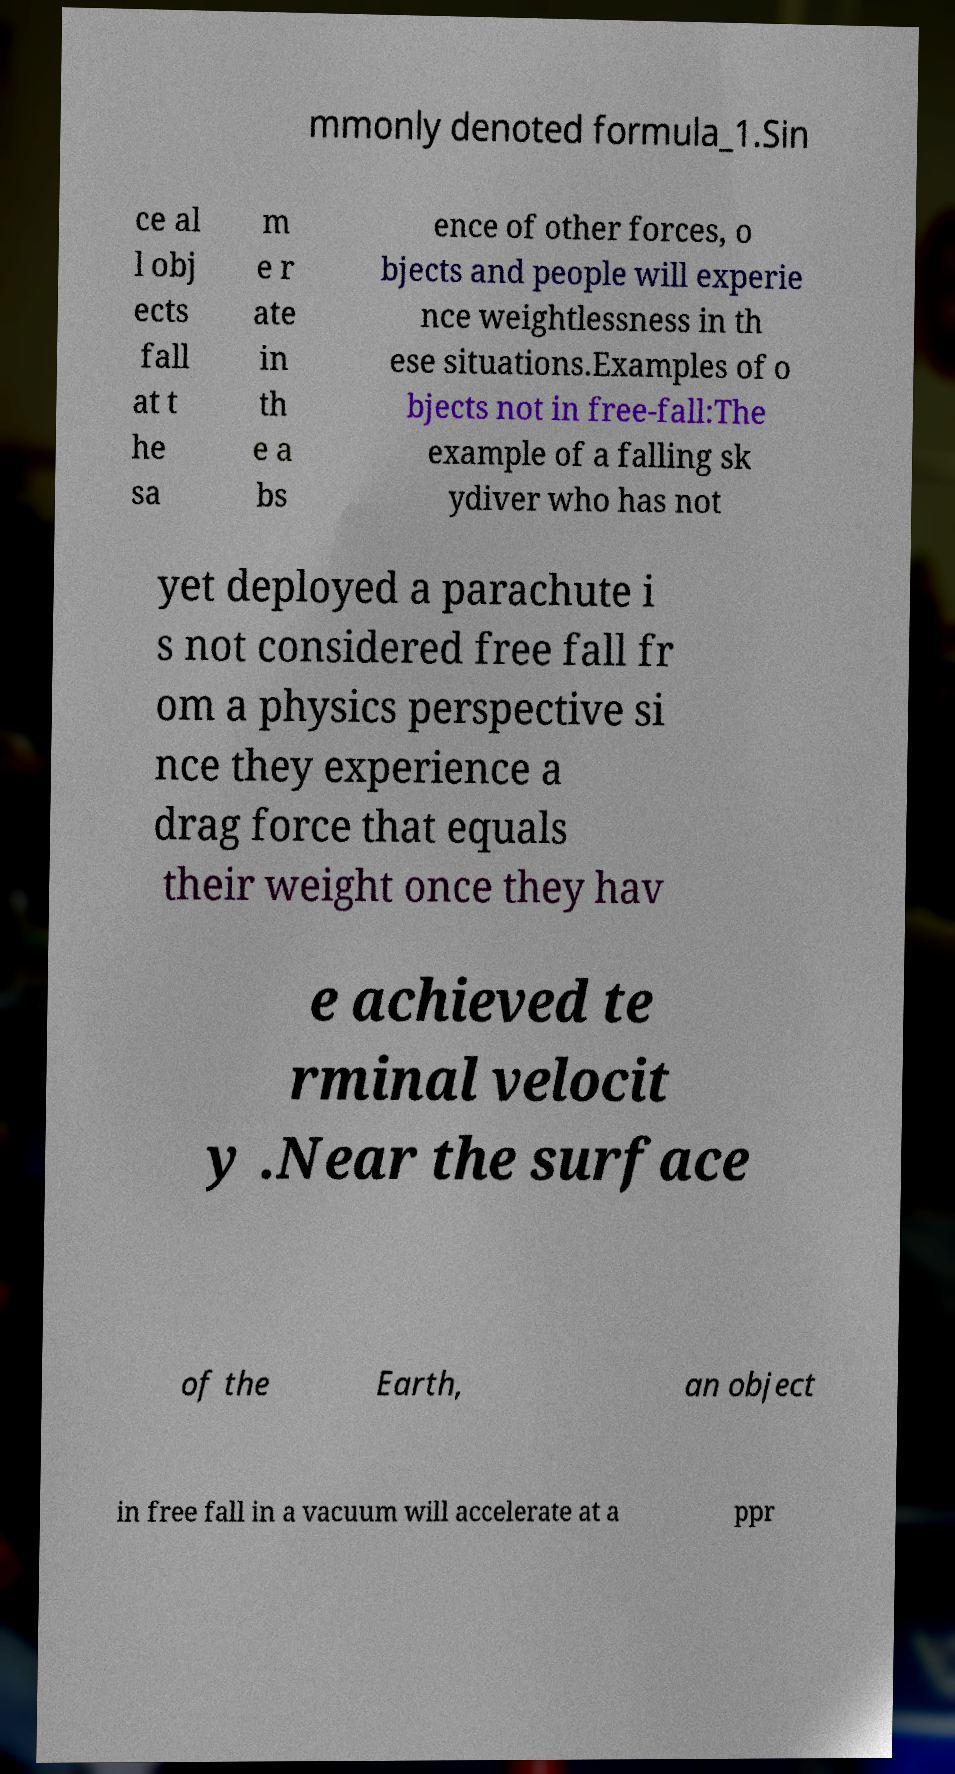There's text embedded in this image that I need extracted. Can you transcribe it verbatim? mmonly denoted formula_1.Sin ce al l obj ects fall at t he sa m e r ate in th e a bs ence of other forces, o bjects and people will experie nce weightlessness in th ese situations.Examples of o bjects not in free-fall:The example of a falling sk ydiver who has not yet deployed a parachute i s not considered free fall fr om a physics perspective si nce they experience a drag force that equals their weight once they hav e achieved te rminal velocit y .Near the surface of the Earth, an object in free fall in a vacuum will accelerate at a ppr 